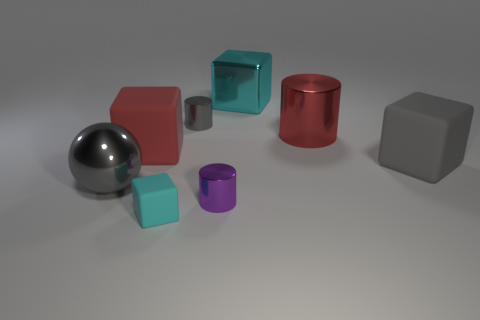What is the size of the cyan metallic block behind the tiny metallic thing in front of the large red matte block?
Your answer should be compact. Large. Are there more small cyan objects than small blue objects?
Give a very brief answer. Yes. Does the matte object on the right side of the big metallic cylinder have the same color as the shiny cube that is on the right side of the big red block?
Give a very brief answer. No. Is there a cylinder that is on the right side of the cyan block that is in front of the small gray metal object?
Offer a very short reply. Yes. Is the number of cyan objects behind the red matte object less than the number of metal objects that are left of the large gray rubber cube?
Your answer should be very brief. Yes. Is the material of the tiny cylinder that is behind the large gray matte block the same as the cyan object in front of the gray matte block?
Offer a very short reply. No. What number of large objects are either rubber objects or gray blocks?
Your answer should be very brief. 2. There is a cyan object that is made of the same material as the gray sphere; what shape is it?
Provide a short and direct response. Cube. Are there fewer red cubes that are in front of the large gray block than purple metallic things?
Make the answer very short. Yes. Is the shape of the large red rubber object the same as the cyan matte thing?
Your answer should be very brief. Yes. 